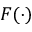<formula> <loc_0><loc_0><loc_500><loc_500>F ( \cdot )</formula> 